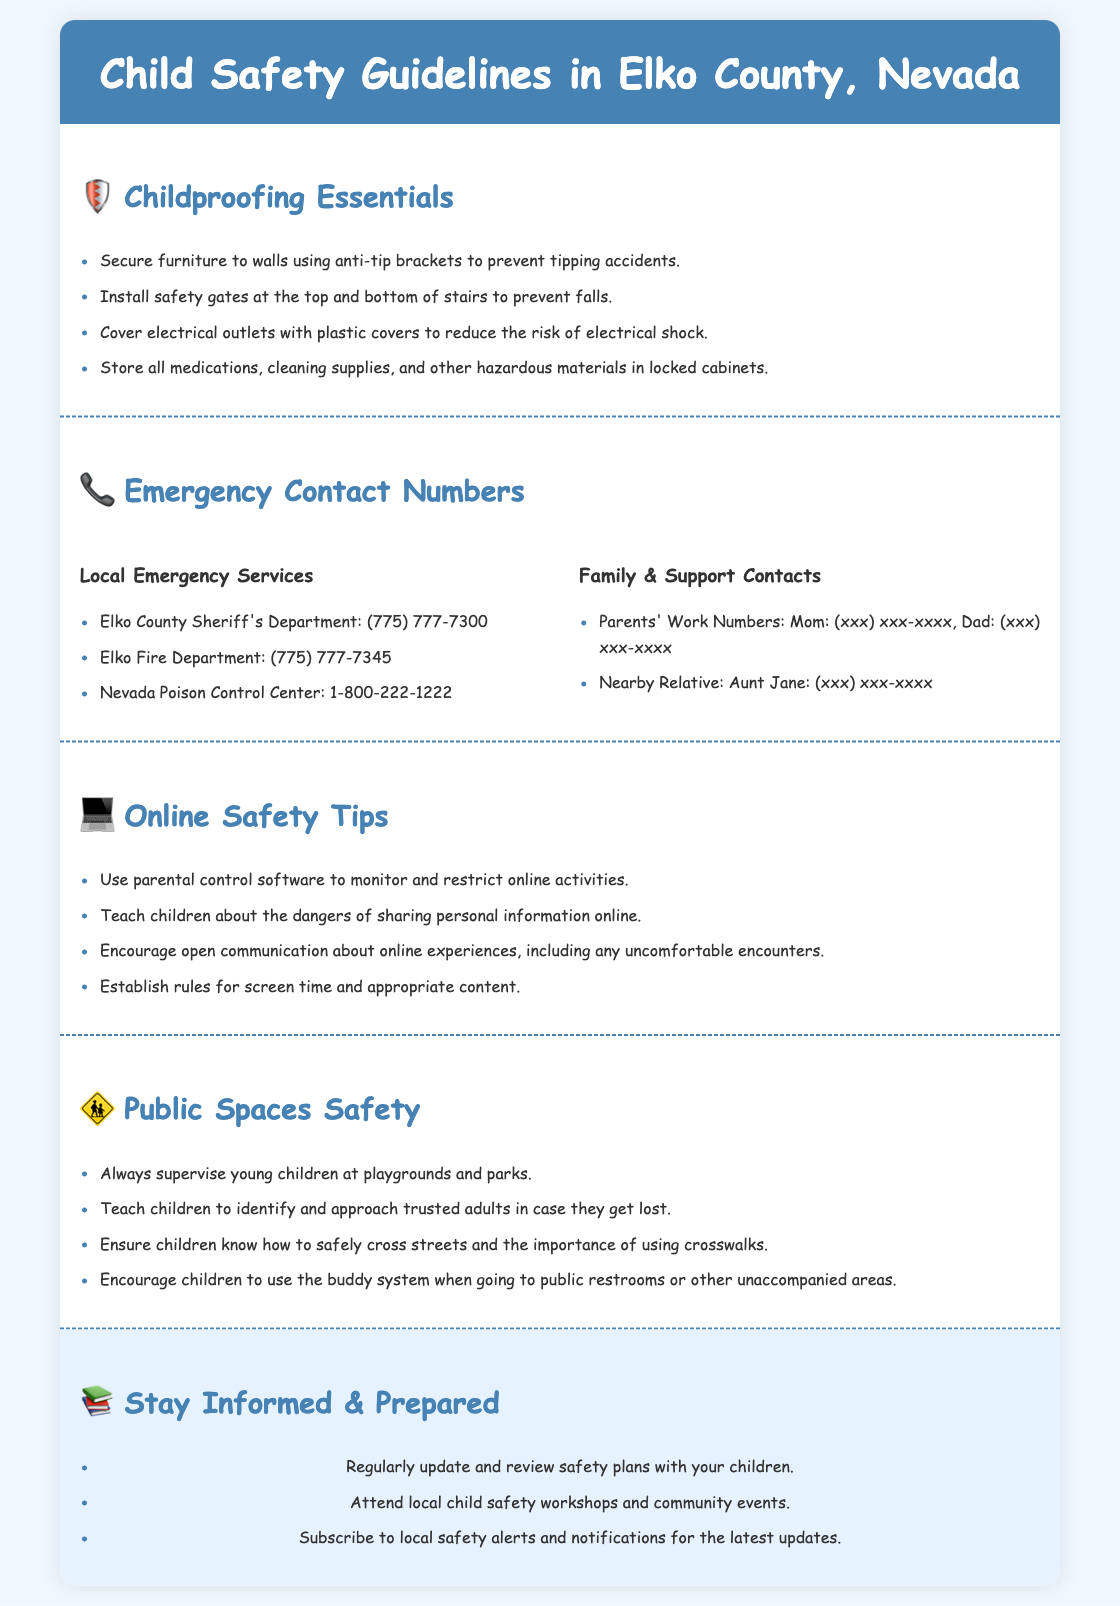What are the four childproofing essentials listed? The document lists four childproofing essentials in a bullet-point format.
Answer: Secure furniture, safety gates, outlet covers, locked cabinets What is the phone number for the Elko County Sheriff's Department? The phone numbers for local emergency services, including the Sheriff's Department, are provided in the document.
Answer: (775) 777-7300 What is a key online safety tip mentioned? The document provides various online safety tips and highlights the importance of discussing online experiences.
Answer: Use parental control software What should children do if they get lost in public? The document advises on safety measures for children in public spaces.
Answer: Approach trusted adults How many contacts are listed under Family & Support Contacts? The document specifies the number of contacts regarding family and support.
Answer: Two contacts 